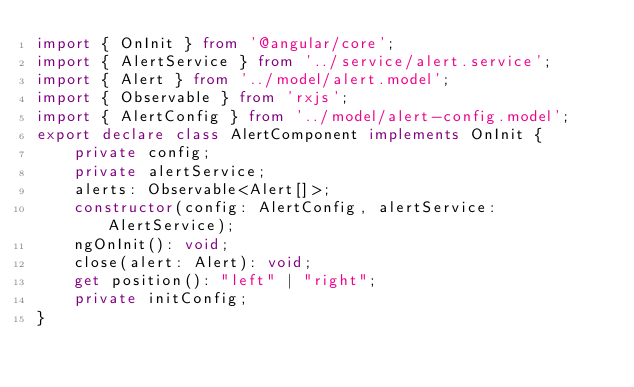<code> <loc_0><loc_0><loc_500><loc_500><_TypeScript_>import { OnInit } from '@angular/core';
import { AlertService } from '../service/alert.service';
import { Alert } from '../model/alert.model';
import { Observable } from 'rxjs';
import { AlertConfig } from '../model/alert-config.model';
export declare class AlertComponent implements OnInit {
    private config;
    private alertService;
    alerts: Observable<Alert[]>;
    constructor(config: AlertConfig, alertService: AlertService);
    ngOnInit(): void;
    close(alert: Alert): void;
    get position(): "left" | "right";
    private initConfig;
}
</code> 